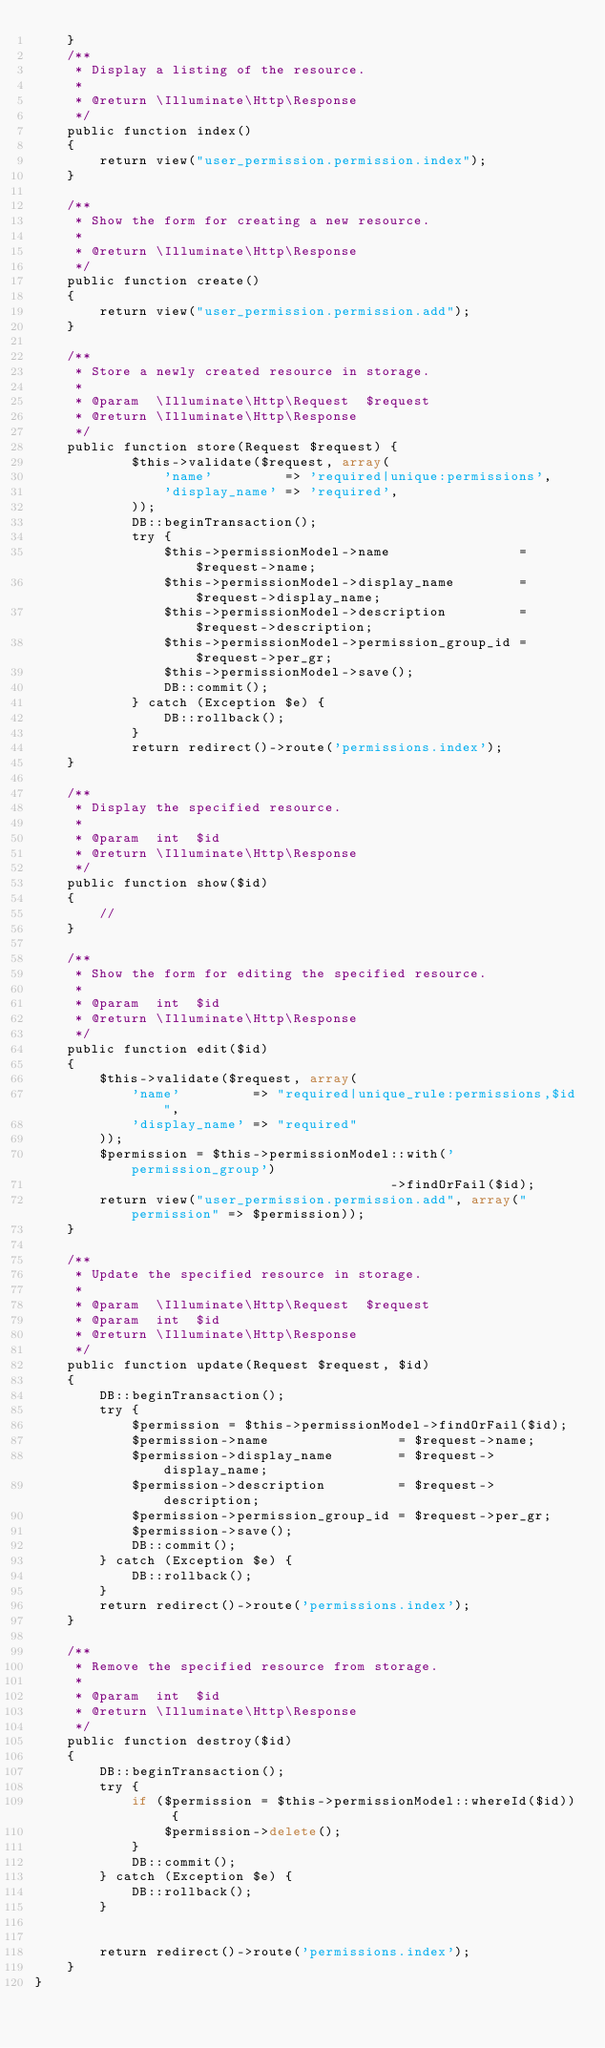<code> <loc_0><loc_0><loc_500><loc_500><_PHP_>    }
    /**
     * Display a listing of the resource.
     *
     * @return \Illuminate\Http\Response
     */
    public function index()
    {
        return view("user_permission.permission.index");
    }

    /**
     * Show the form for creating a new resource.
     *
     * @return \Illuminate\Http\Response
     */
    public function create()
    {
        return view("user_permission.permission.add");
    }

    /**
     * Store a newly created resource in storage.
     *
     * @param  \Illuminate\Http\Request  $request
     * @return \Illuminate\Http\Response
     */
    public function store(Request $request) {
            $this->validate($request, array(
                'name'         => 'required|unique:permissions',
                'display_name' => 'required',
            ));
            DB::beginTransaction();
            try {
                $this->permissionModel->name                = $request->name;
                $this->permissionModel->display_name        = $request->display_name;
                $this->permissionModel->description         = $request->description;
                $this->permissionModel->permission_group_id = $request->per_gr;
                $this->permissionModel->save();
                DB::commit();
            } catch (Exception $e) {
                DB::rollback();
            }
            return redirect()->route('permissions.index');
    }

    /**
     * Display the specified resource.
     *
     * @param  int  $id
     * @return \Illuminate\Http\Response
     */
    public function show($id)
    {
        //
    }

    /**
     * Show the form for editing the specified resource.
     *
     * @param  int  $id
     * @return \Illuminate\Http\Response
     */
    public function edit($id)
    {
        $this->validate($request, array(
            'name'         => "required|unique_rule:permissions,$id",
            'display_name' => "required"
        ));
        $permission = $this->permissionModel::with('permission_group')
                                            ->findOrFail($id);   
        return view("user_permission.permission.add", array("permission" => $permission));
    }

    /**
     * Update the specified resource in storage.
     *
     * @param  \Illuminate\Http\Request  $request
     * @param  int  $id
     * @return \Illuminate\Http\Response
     */
    public function update(Request $request, $id)
    {
        DB::beginTransaction();
        try {
            $permission = $this->permissionModel->findOrFail($id);
            $permission->name                = $request->name;
            $permission->display_name        = $request->display_name;
            $permission->description         = $request->description;
            $permission->permission_group_id = $request->per_gr;
            $permission->save();
            DB::commit();
        } catch (Exception $e) {
            DB::rollback();
        }
        return redirect()->route('permissions.index');
    }

    /**
     * Remove the specified resource from storage.
     *
     * @param  int  $id
     * @return \Illuminate\Http\Response
     */
    public function destroy($id)
    {
        DB::beginTransaction();
        try {
            if ($permission = $this->permissionModel::whereId($id)) {
                $permission->delete();
            }
            DB::commit();
        } catch (Exception $e) {
            DB::rollback();
        }
        
        
        return redirect()->route('permissions.index');
    }
}
</code> 